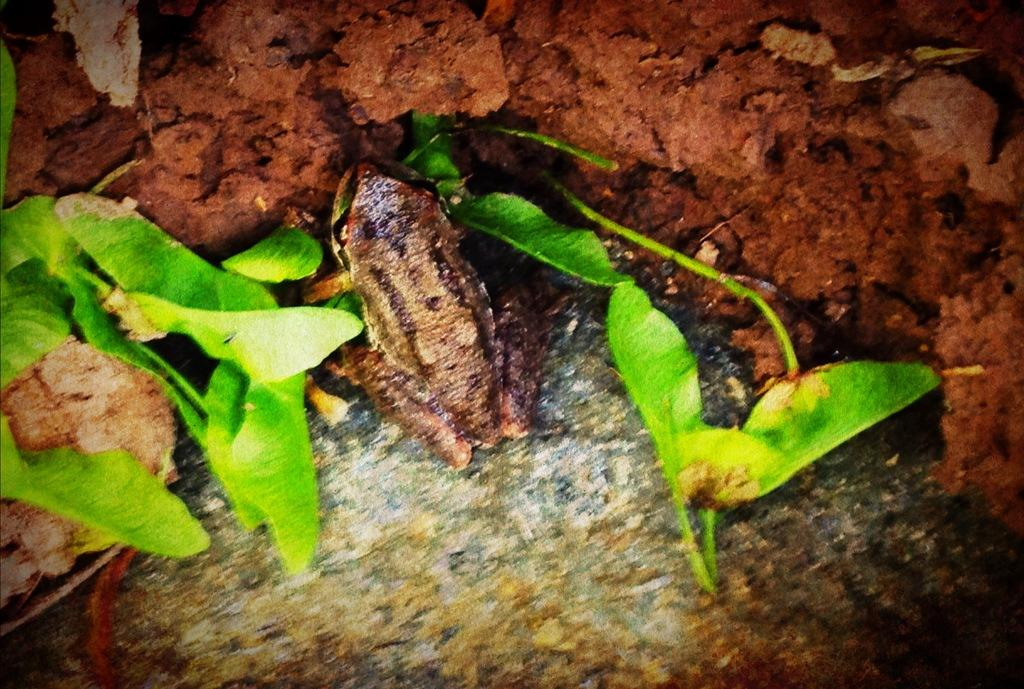What type of vegetation is present in the image? There are green-colored leaves in the image. What type of animal can be seen in the image? There is a brown-colored frog in the image. What type of prison can be seen in the image? There is no prison present in the image; it features green-colored leaves and a brown-colored frog. What emotion does the frog display in the image? The image does not show any emotions of the frog, as it is a still image and does not depict facial expressions or body language. 